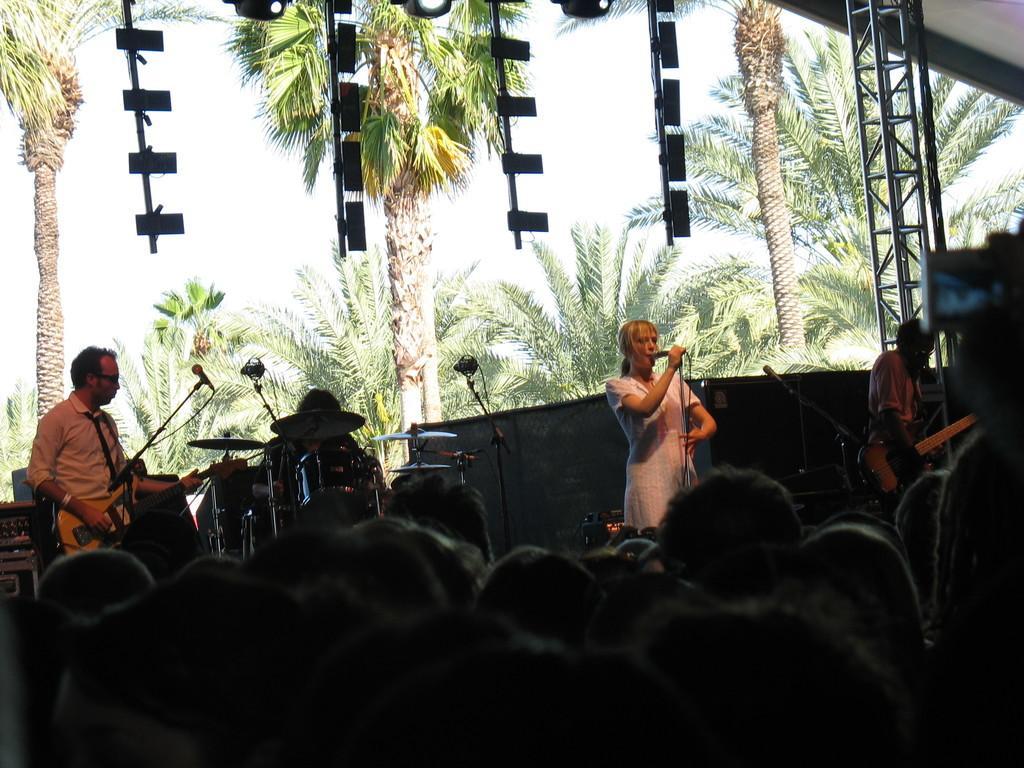How would you summarize this image in a sentence or two? In this image I see 2 men who are holding the guitar and I see a woman over here and lot of people over here. In the background I see lot of trees, a person near the drums and the rod 